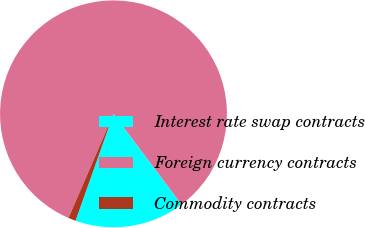Convert chart. <chart><loc_0><loc_0><loc_500><loc_500><pie_chart><fcel>Interest rate swap contracts<fcel>Foreign currency contracts<fcel>Commodity contracts<nl><fcel>15.68%<fcel>83.25%<fcel>1.06%<nl></chart> 